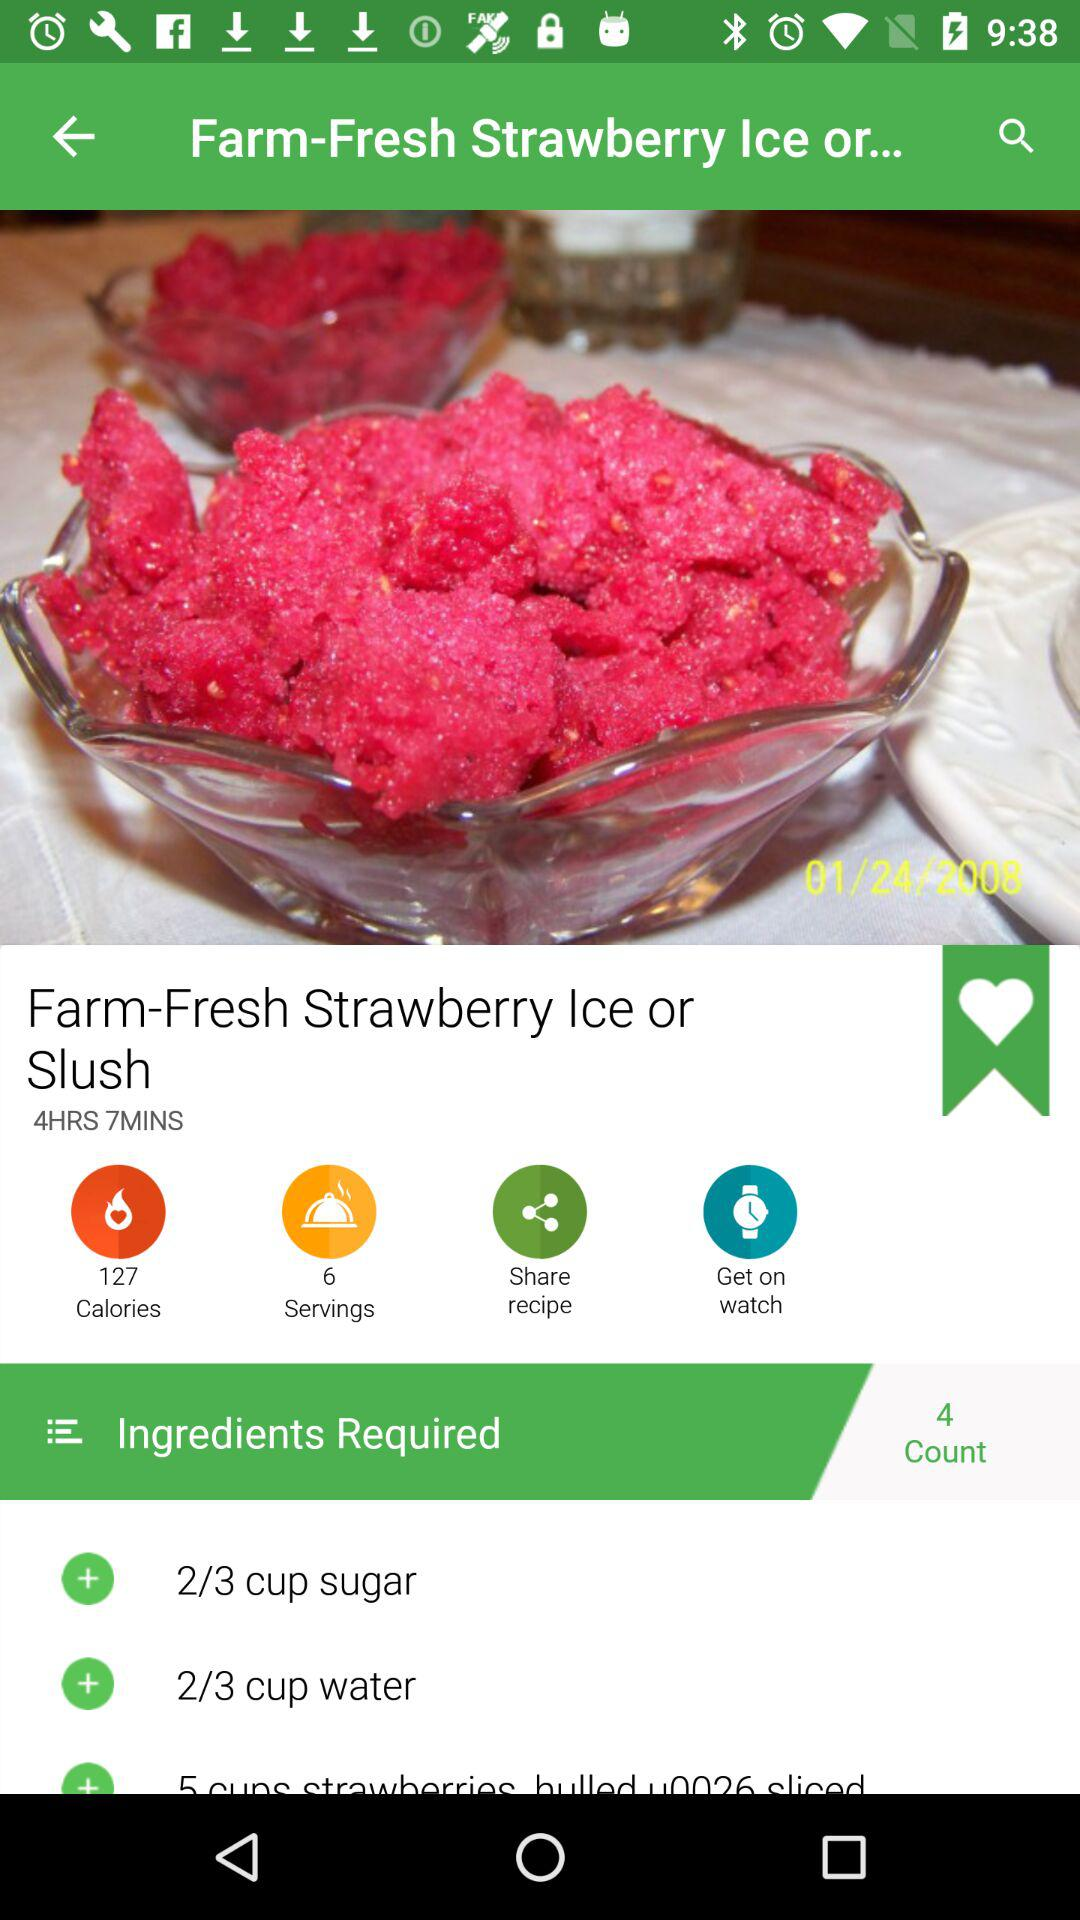What is the total preparation time for the dish? The total preparation time for the dish is 4 hours 7 minutes. 